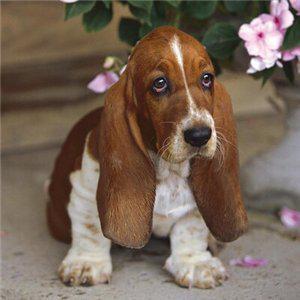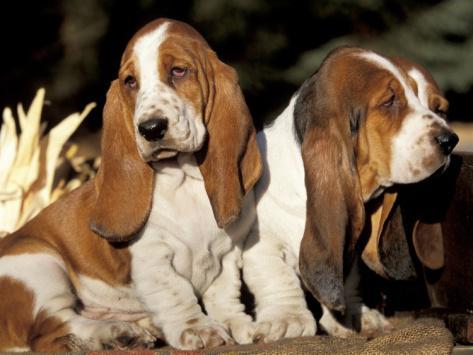The first image is the image on the left, the second image is the image on the right. Considering the images on both sides, is "There are more basset hounds in the right image than in the left." valid? Answer yes or no. Yes. The first image is the image on the left, the second image is the image on the right. Examine the images to the left and right. Is the description "There is one dog in the left image" accurate? Answer yes or no. Yes. 